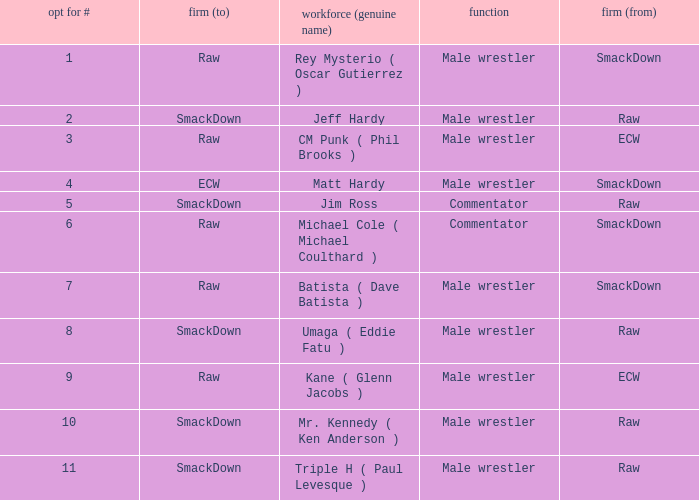What role did Pick # 10 have? Male wrestler. 